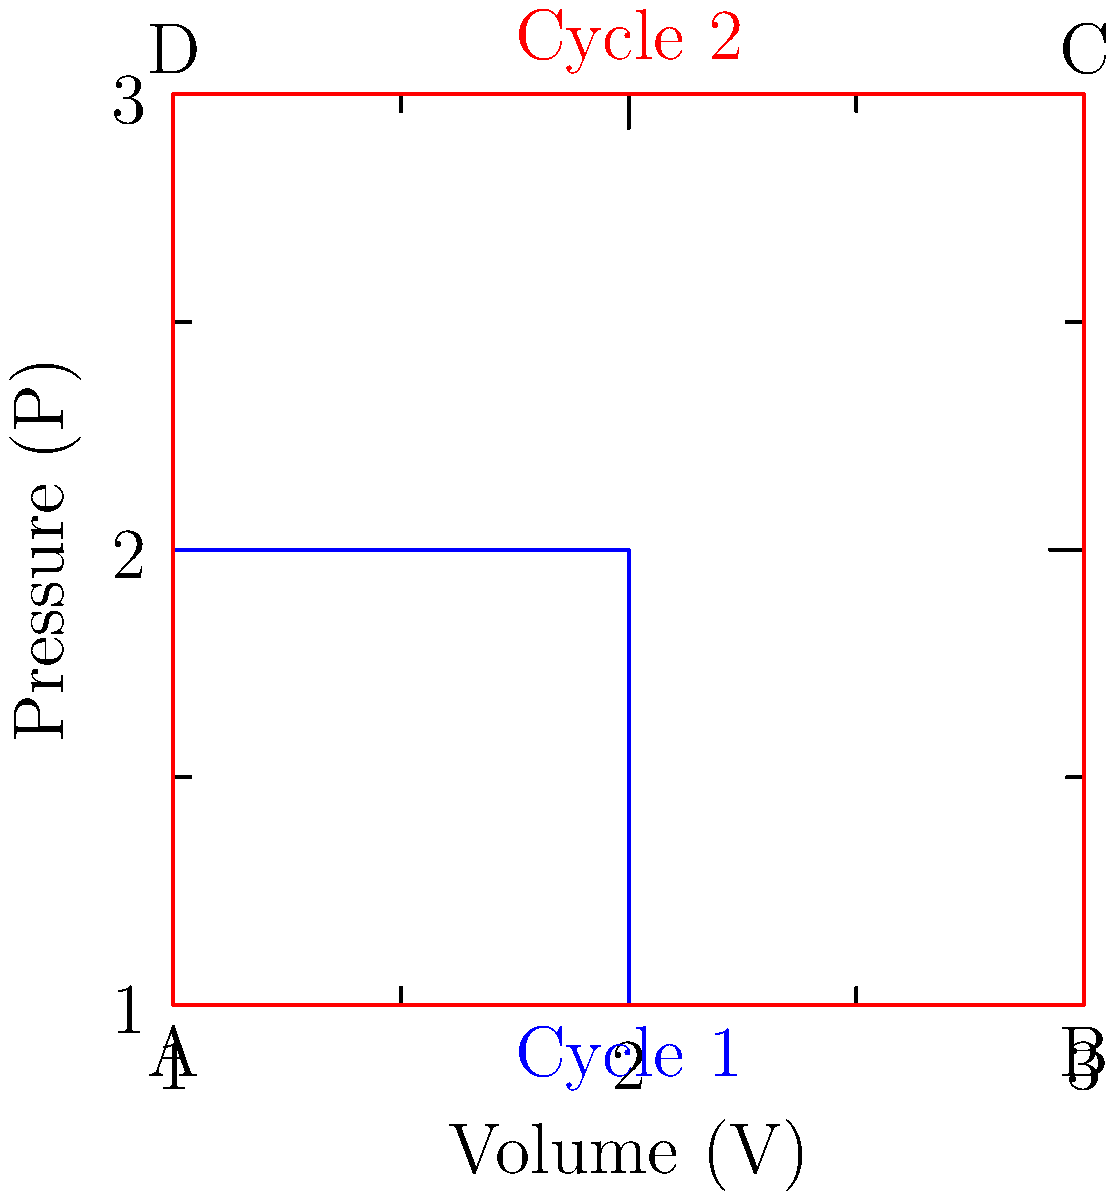As a researcher studying alternative therapies, you come across a study comparing the efficiency of different engine cycles. The pressure-volume (P-V) diagrams for two cycles are shown above. Cycle 1 (blue) operates between pressures of 1 and 2 units, while Cycle 2 (red) operates between 1 and 3 units. Both cycles have the same minimum and maximum volumes. Which cycle is more efficient and why? To determine which cycle is more efficient, we need to consider the work done by each cycle and the heat input required. The efficiency of a thermodynamic cycle is given by:

$$ \eta = \frac{W_{net}}{Q_{in}} $$

Where $W_{net}$ is the net work done by the cycle, and $Q_{in}$ is the heat input.

1. Work done: The work done by a cycle is represented by the area enclosed by the P-V diagram. 
   - Cycle 2 (red) encloses a larger area than Cycle 1 (blue), indicating more work done.

2. Heat input: The heat input is proportional to the maximum temperature reached in the cycle. In a P-V diagram, higher pressure at the same volume indicates higher temperature.
   - Cycle 2 reaches a higher maximum pressure (3 units) compared to Cycle 1 (2 units), indicating a higher maximum temperature and thus a larger heat input.

3. Efficiency comparison: 
   - Cycle 2 produces more work but also requires more heat input.
   - The relative increase in work output for Cycle 2 is greater than the relative increase in heat input when compared to Cycle 1.

4. Carnot efficiency: The maximum possible efficiency for any heat engine is given by the Carnot efficiency:

   $$ \eta_{Carnot} = 1 - \frac{T_{cold}}{T_{hot}} $$

   Where $T_{cold}$ and $T_{hot}$ are the minimum and maximum temperatures in the cycle.
   - Cycle 2 has a higher $T_{hot}$ (corresponding to the higher maximum pressure), resulting in a higher Carnot efficiency.

5. Conclusion: Cycle 2 is more efficient because it produces relatively more work for the increased heat input, and it operates closer to the maximum possible (Carnot) efficiency for its temperature range.
Answer: Cycle 2 (red) is more efficient due to its higher work output relative to heat input and closer approach to Carnot efficiency. 